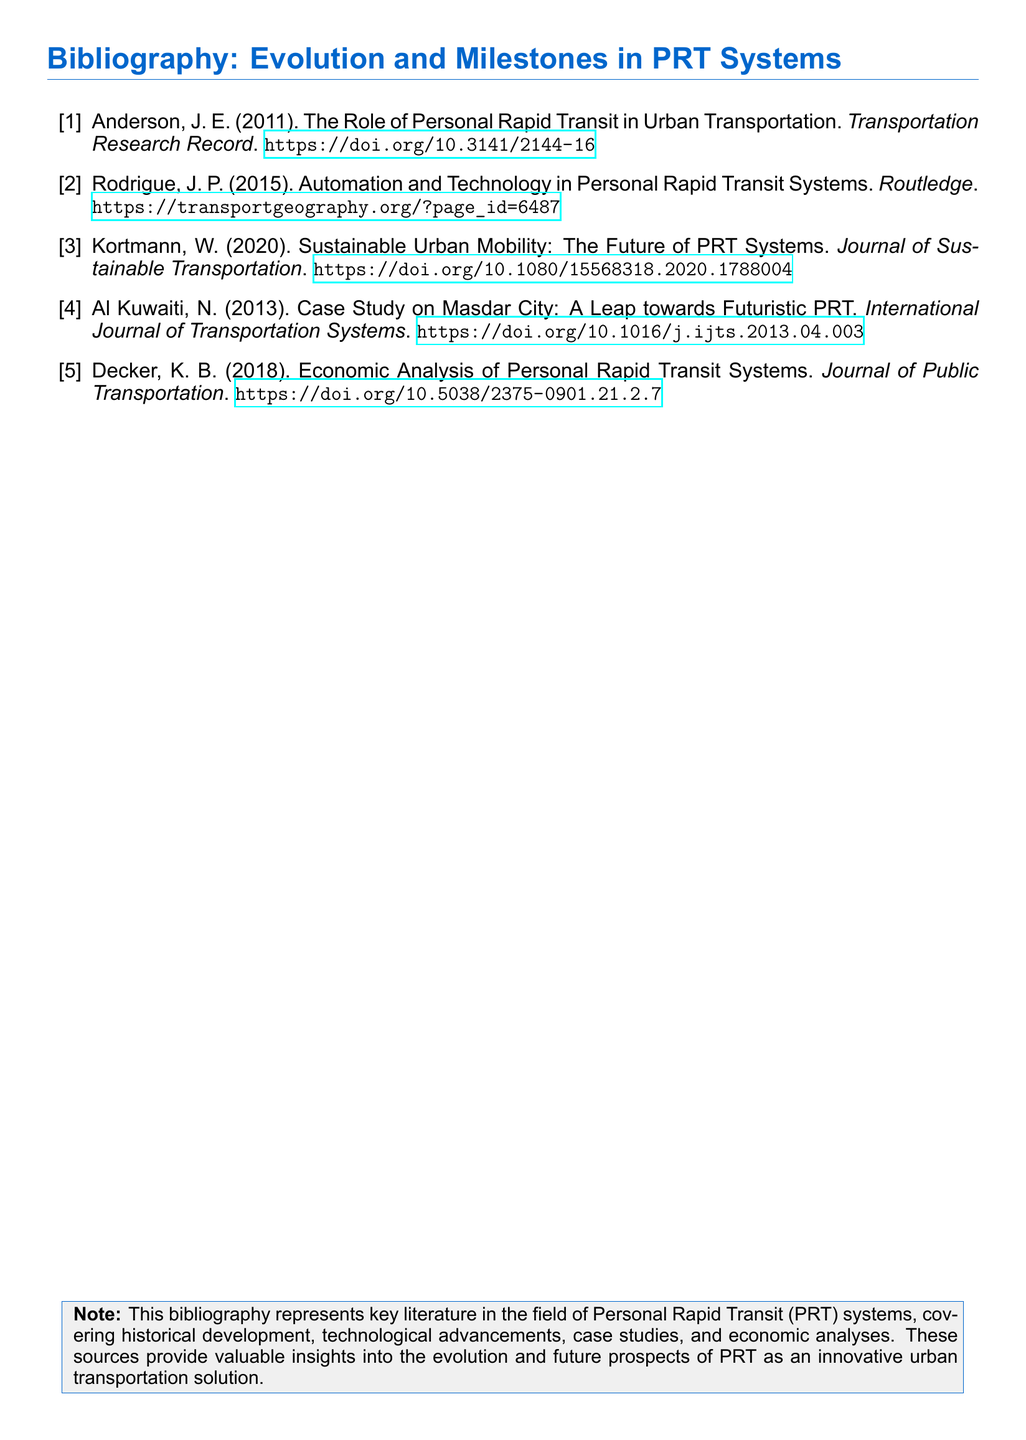what is the author of the first entry? The first entry is authored by J. E. Anderson.
Answer: J. E. Anderson what is the publication year of the second entry? The second entry was published in 2015.
Answer: 2015 which journal published the economic analysis article? The economic analysis article is published in the Journal of Public Transportation.
Answer: Journal of Public Transportation what is the title of the third entry? The title of the third entry is "Sustainable Urban Mobility: The Future of PRT Systems."
Answer: Sustainable Urban Mobility: The Future of PRT Systems who conducted a case study on Masdar City? The case study on Masdar City was conducted by N. Al Kuwaiti.
Answer: N. Al Kuwaiti how many entries are included in the bibliography? There are five entries included in the bibliography.
Answer: five what type of transportation system does the bibliography focus on? The bibliography focuses on Personal Rapid Transit systems.
Answer: Personal Rapid Transit systems what is the main subject covered in this bibliography? The main subject covered is the evolution and future prospects of PRT systems.
Answer: evolution and future prospects of PRT systems 